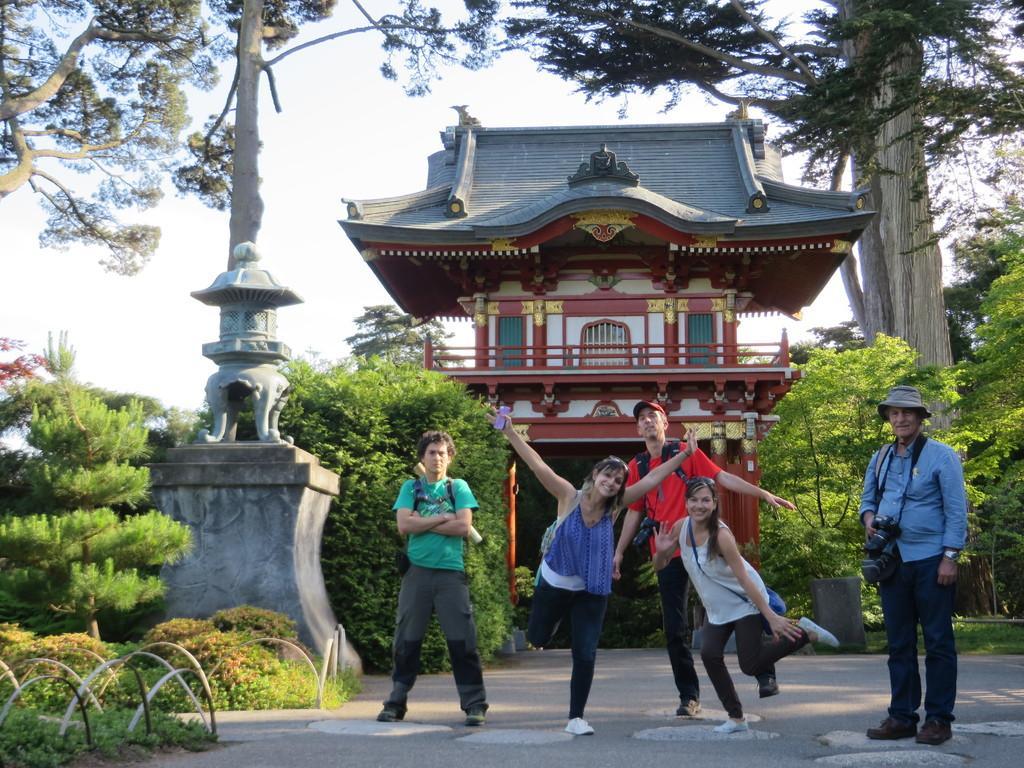What are the people in the image doing? The persons standing on the road in the center of the image are likely waiting or standing. What can be seen in the background of the image? There is a building, a pillar, trees, and the sky visible in the background of the image. What statement is the person wearing on their head in the image? There is no person wearing a statement on their head in the image. Can you describe the hat that the person is resting on the pillar in the image? There is no hat present in the image, nor is there a person resting on the pillar. 